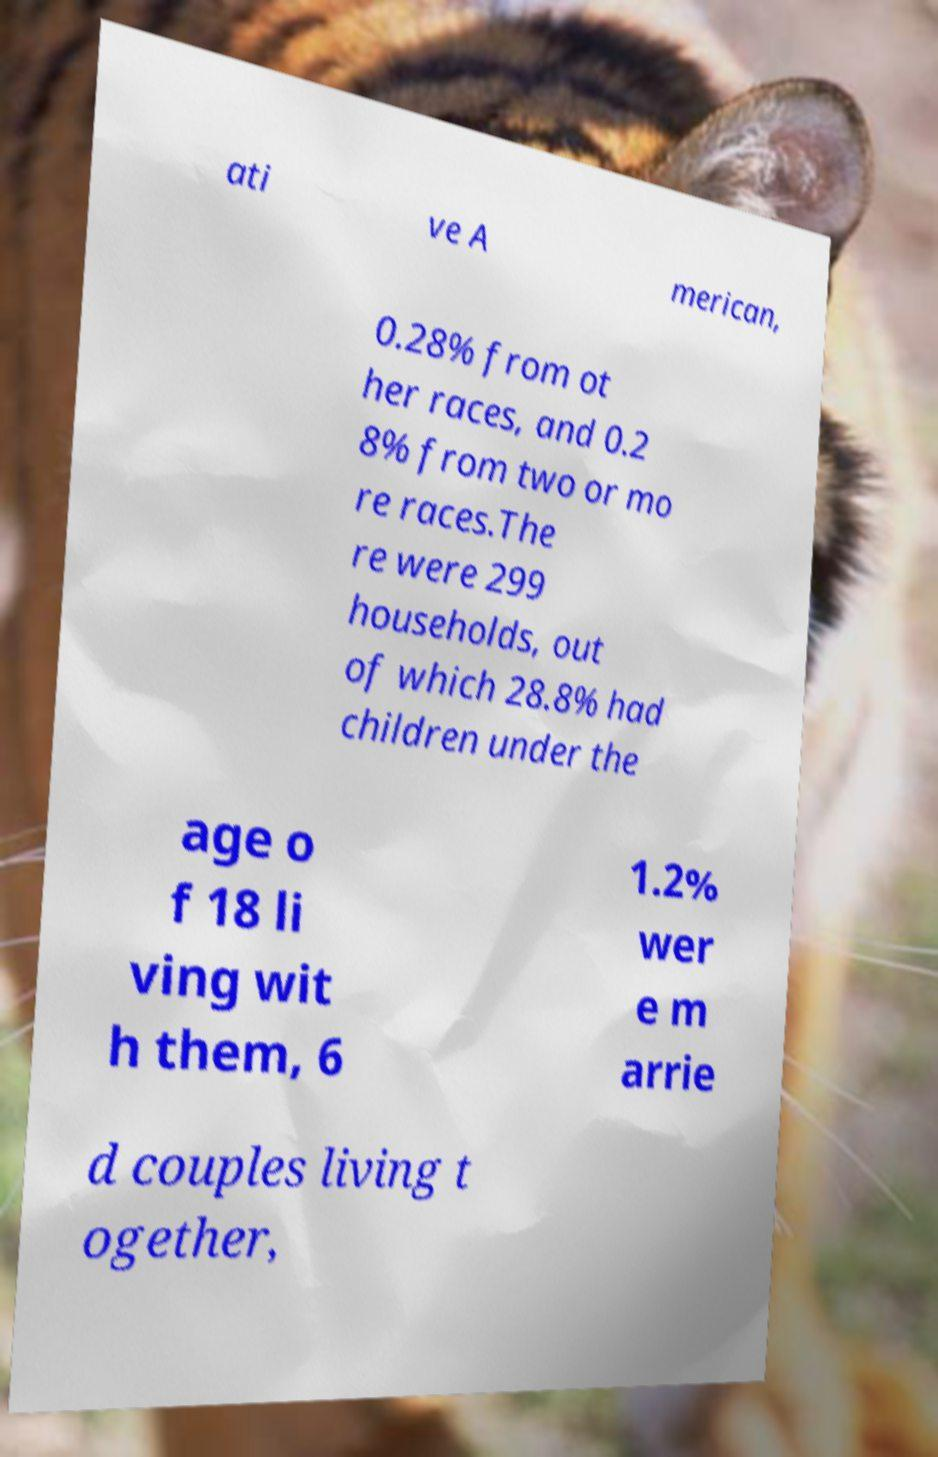Can you accurately transcribe the text from the provided image for me? ati ve A merican, 0.28% from ot her races, and 0.2 8% from two or mo re races.The re were 299 households, out of which 28.8% had children under the age o f 18 li ving wit h them, 6 1.2% wer e m arrie d couples living t ogether, 